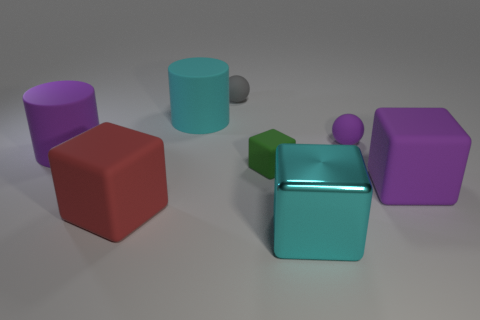Add 2 brown rubber blocks. How many objects exist? 10 Subtract all cylinders. How many objects are left? 6 Add 4 purple cubes. How many purple cubes exist? 5 Subtract 0 gray cubes. How many objects are left? 8 Subtract all red blocks. Subtract all gray rubber things. How many objects are left? 6 Add 1 purple rubber things. How many purple rubber things are left? 4 